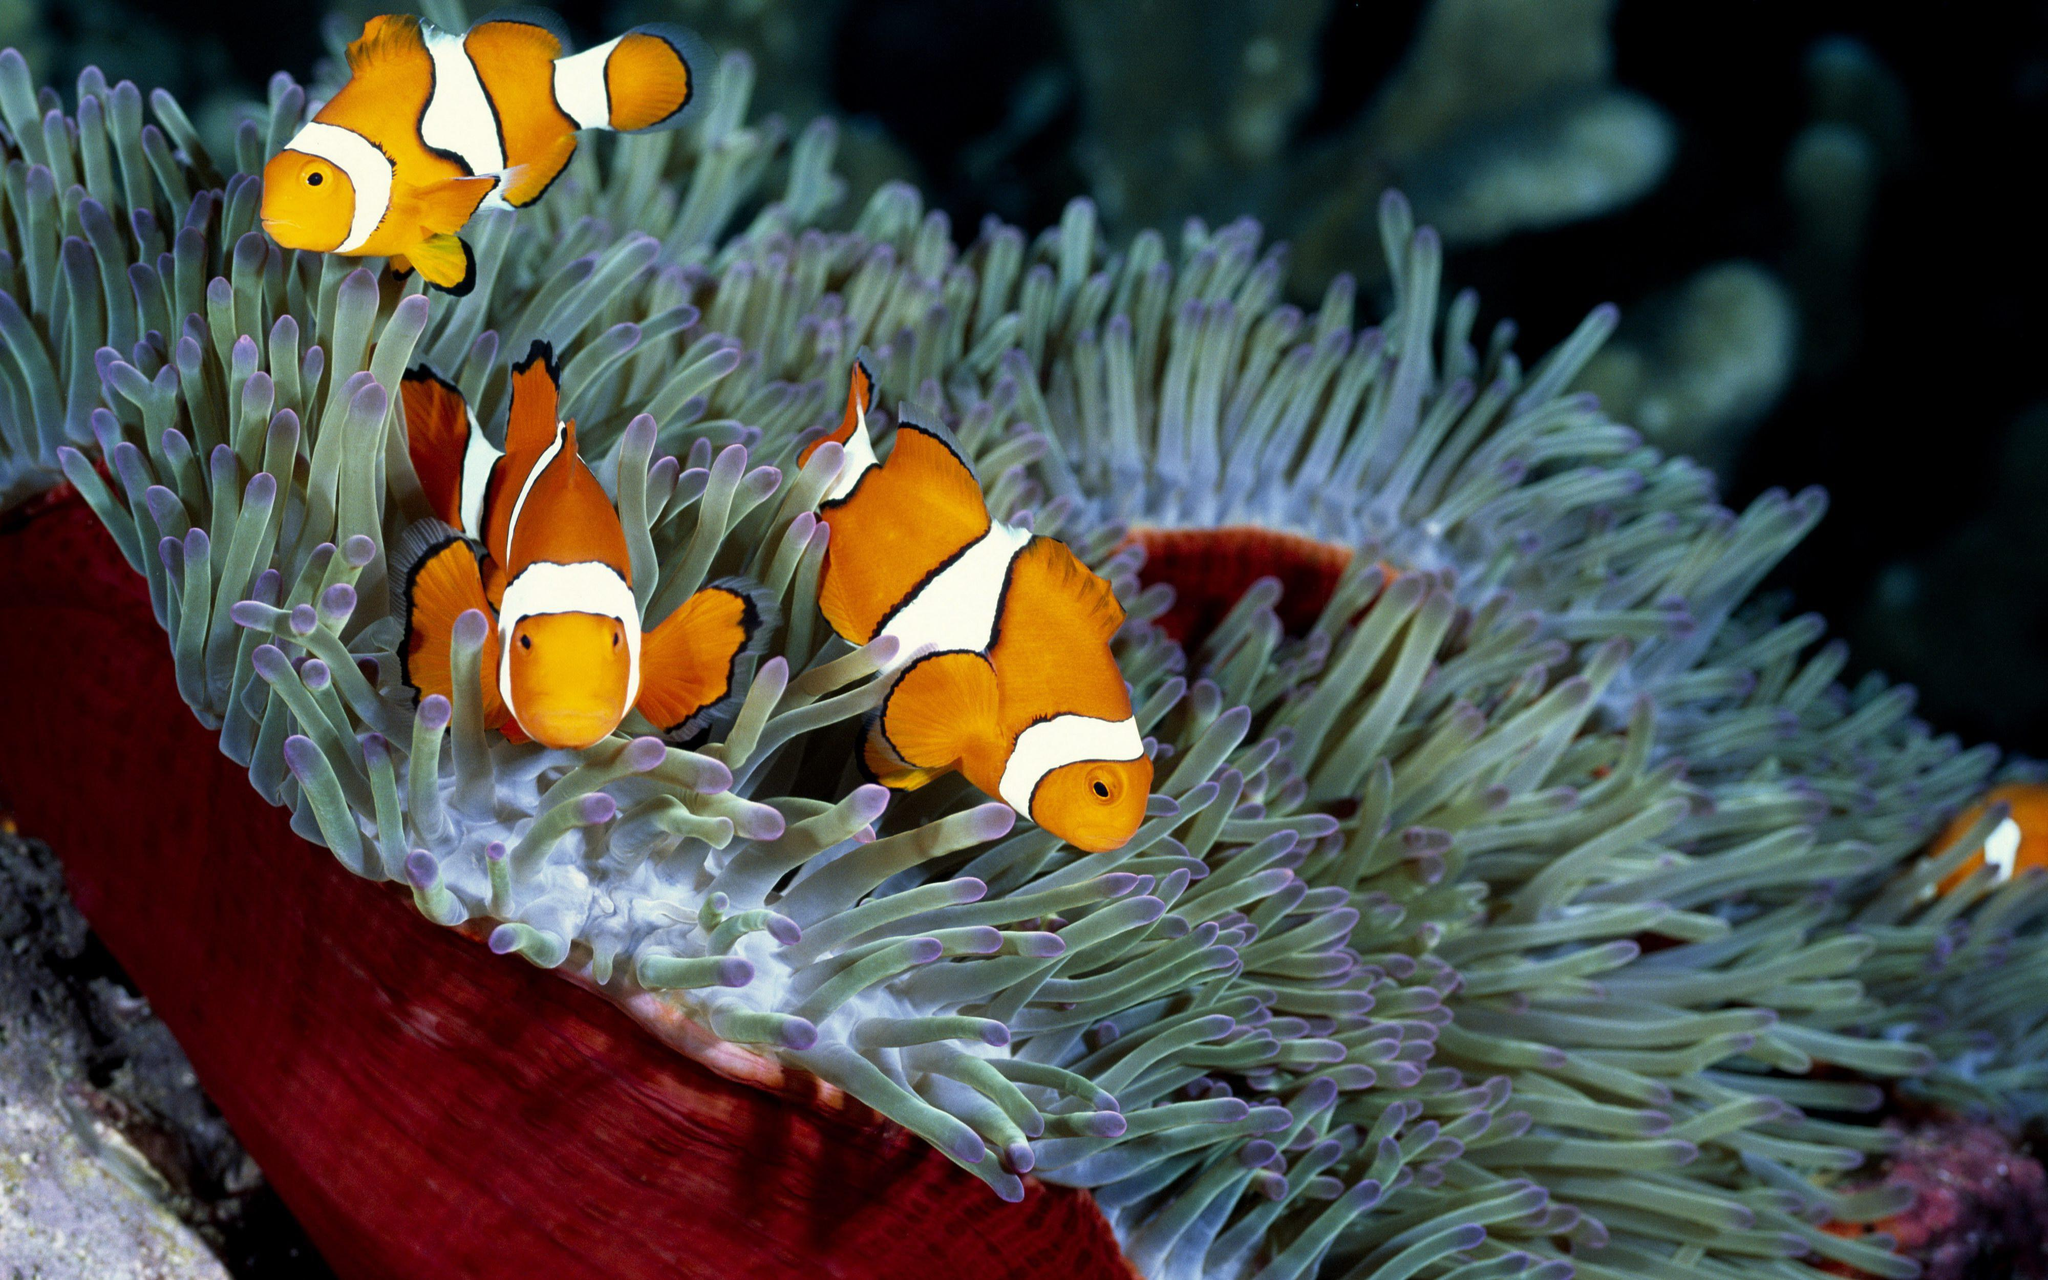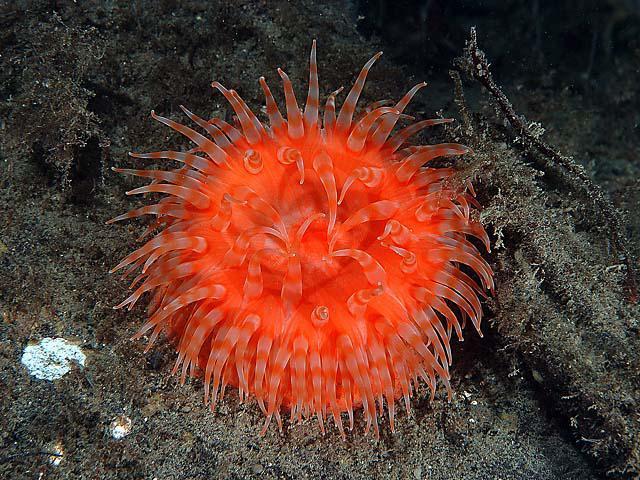The first image is the image on the left, the second image is the image on the right. For the images displayed, is the sentence "Several fish are swimming in one of the images." factually correct? Answer yes or no. Yes. The first image is the image on the left, the second image is the image on the right. For the images shown, is this caption "An image contains at least three clown fish." true? Answer yes or no. Yes. 